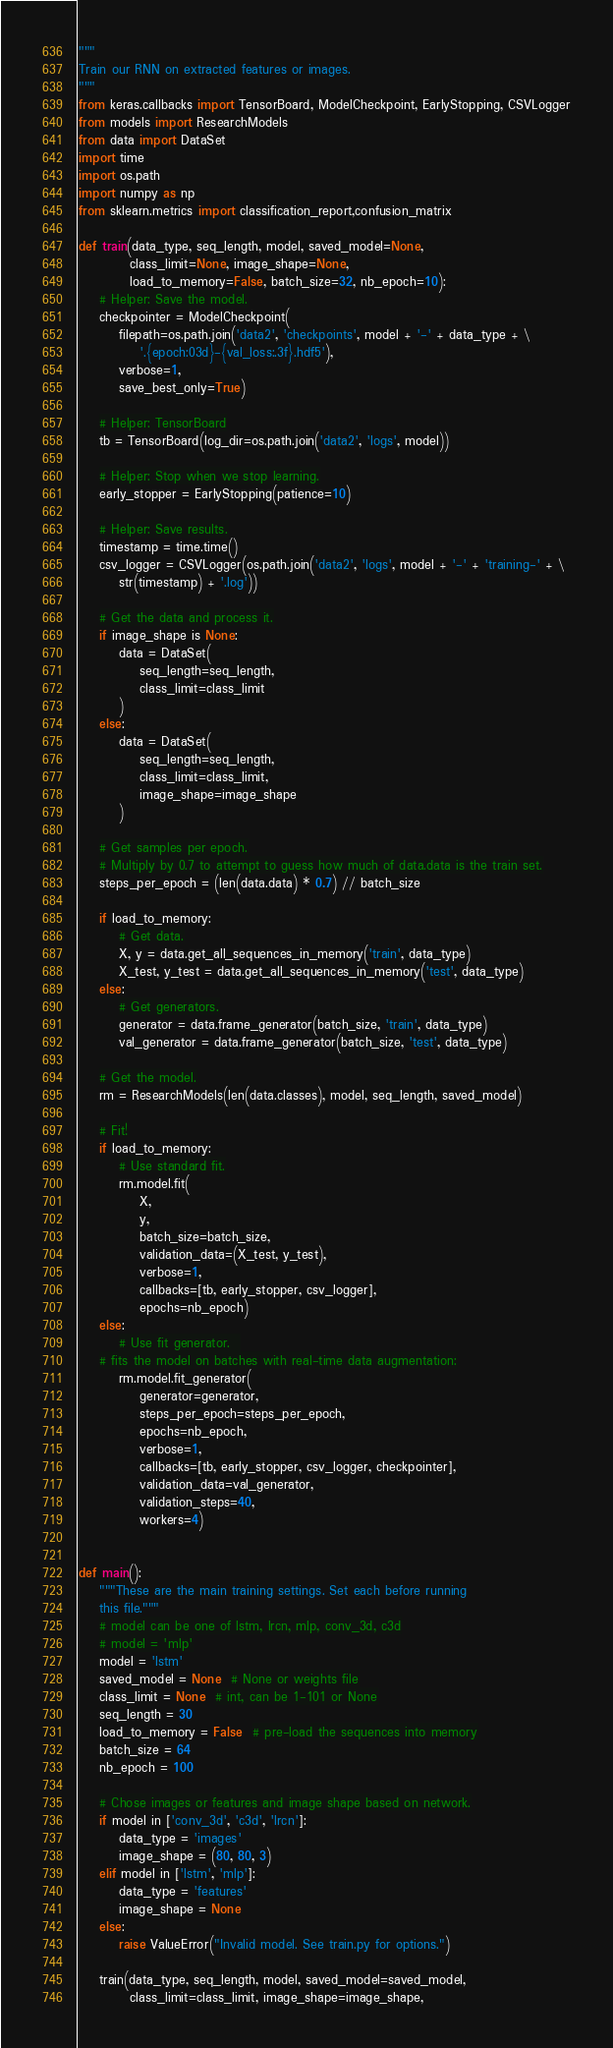<code> <loc_0><loc_0><loc_500><loc_500><_Python_>"""
Train our RNN on extracted features or images.
"""
from keras.callbacks import TensorBoard, ModelCheckpoint, EarlyStopping, CSVLogger
from models import ResearchModels
from data import DataSet
import time
import os.path
import numpy as np
from sklearn.metrics import classification_report,confusion_matrix

def train(data_type, seq_length, model, saved_model=None,
          class_limit=None, image_shape=None,
          load_to_memory=False, batch_size=32, nb_epoch=10):
    # Helper: Save the model.
    checkpointer = ModelCheckpoint(
        filepath=os.path.join('data2', 'checkpoints', model + '-' + data_type + \
            '.{epoch:03d}-{val_loss:.3f}.hdf5'),
        verbose=1,
        save_best_only=True)

    # Helper: TensorBoard
    tb = TensorBoard(log_dir=os.path.join('data2', 'logs', model))

    # Helper: Stop when we stop learning.
    early_stopper = EarlyStopping(patience=10)

    # Helper: Save results.
    timestamp = time.time()
    csv_logger = CSVLogger(os.path.join('data2', 'logs', model + '-' + 'training-' + \
        str(timestamp) + '.log'))

    # Get the data and process it.
    if image_shape is None:
        data = DataSet(
            seq_length=seq_length,
            class_limit=class_limit
        )
    else:
        data = DataSet(
            seq_length=seq_length,
            class_limit=class_limit,
            image_shape=image_shape
        )

    # Get samples per epoch.
    # Multiply by 0.7 to attempt to guess how much of data.data is the train set.
    steps_per_epoch = (len(data.data) * 0.7) // batch_size

    if load_to_memory:
        # Get data.
        X, y = data.get_all_sequences_in_memory('train', data_type)
        X_test, y_test = data.get_all_sequences_in_memory('test', data_type)
    else:
        # Get generators.
        generator = data.frame_generator(batch_size, 'train', data_type)
        val_generator = data.frame_generator(batch_size, 'test', data_type)

    # Get the model.
    rm = ResearchModels(len(data.classes), model, seq_length, saved_model)

    # Fit!
    if load_to_memory:
        # Use standard fit.
        rm.model.fit(
            X,
            y,
            batch_size=batch_size,
            validation_data=(X_test, y_test),
            verbose=1,
            callbacks=[tb, early_stopper, csv_logger],
            epochs=nb_epoch)
    else:
        # Use fit generator.  
    # fits the model on batches with real-time data augmentation:
        rm.model.fit_generator(
            generator=generator,
            steps_per_epoch=steps_per_epoch,
            epochs=nb_epoch,
            verbose=1,
            callbacks=[tb, early_stopper, csv_logger, checkpointer],
            validation_data=val_generator,
            validation_steps=40,
            workers=4)


def main():
    """These are the main training settings. Set each before running
    this file."""
    # model can be one of lstm, lrcn, mlp, conv_3d, c3d
    # model = 'mlp'
    model = 'lstm'
    saved_model = None  # None or weights file
    class_limit = None  # int, can be 1-101 or None
    seq_length = 30
    load_to_memory = False  # pre-load the sequences into memory
    batch_size = 64
    nb_epoch = 100

    # Chose images or features and image shape based on network.
    if model in ['conv_3d', 'c3d', 'lrcn']:
        data_type = 'images'
        image_shape = (80, 80, 3)
    elif model in ['lstm', 'mlp']:
        data_type = 'features'
        image_shape = None
    else:
        raise ValueError("Invalid model. See train.py for options.")

    train(data_type, seq_length, model, saved_model=saved_model,
          class_limit=class_limit, image_shape=image_shape,</code> 